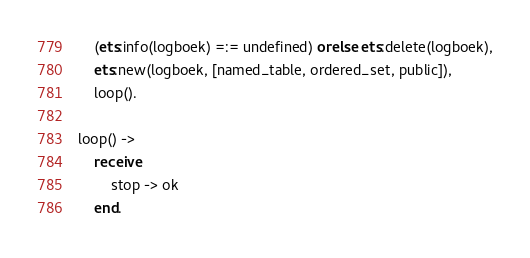<code> <loc_0><loc_0><loc_500><loc_500><_Erlang_>	(ets:info(logboek) =:= undefined) orelse ets:delete(logboek),
	ets:new(logboek, [named_table, ordered_set, public]),		
	loop().

loop() -> 
	receive
		stop -> ok
	end. 
</code> 